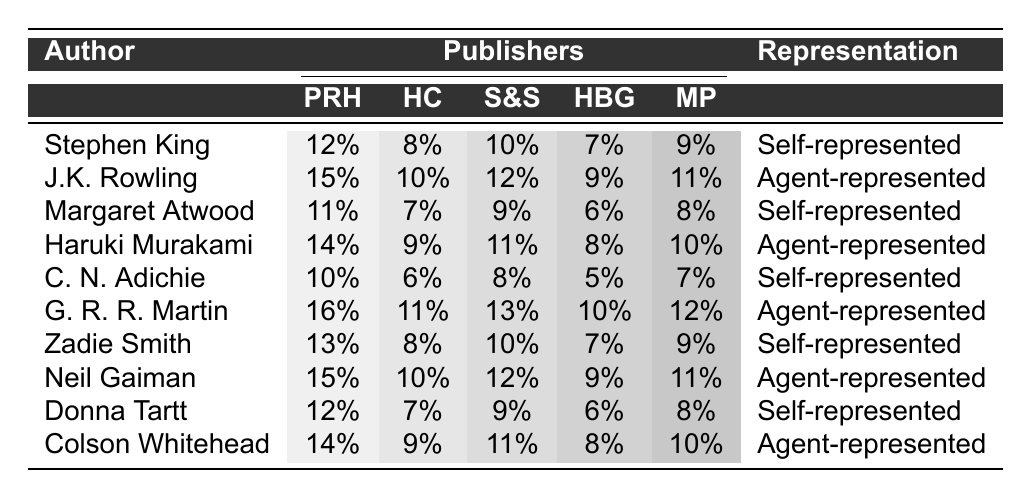What's the highest royalty rate for self-represented authors? By looking at the table, the highest royalty rate for self-represented authors is found under G. R. R. Martin, which is 16%.
Answer: 16% What is the lowest royalty rate offered by Penguin Random House? Upon examining the table, the lowest royalty rate offered by Penguin Random House is 10%, which applies to Chimamanda Ngozi Adichie.
Answer: 10% How many authors are self-represented? Counting the authors listed under the "Representation" column that state "Self-represented," there are five such authors: Stephen King, Margaret Atwood, Chimamanda Ngozi Adichie, Zadie Smith, and Donna Tartt.
Answer: 5 What is the average royalty rate for agent-represented authors? First, I will sum the royalty rates for agent-represented authors: (15 + 10 + 14 + 16 + 15 + 14) = 84. Next, I will divide by the number of authors, which is 6. So, the average is 84/6 = 14%.
Answer: 14% Is J.K. Rowling's royalty rate higher than Neil Gaiman's? Checking the rates, J.K. Rowling has a rate of 15% while Neil Gaiman has a rate of 15%, which means J.K. Rowling's rate is not higher.
Answer: No Which author has the highest average royalty rate across all publishers? To find this, I calculate each author's total royalty rate and divide by the number of publishers. Stephen King's total is 56 (12+8+10+7+9), average = 11.2; J.K. Rowling's total is 57 (15+10+12+9+11), average = 11.4; and so on for each author. Haruki Murakami has the highest total of 52 (14+9+11+8+10) for an average of 10.4%. Comparing all, G. R. R. Martin has the overall highest at an average of 12.4%.
Answer: G. R. R. Martin What percentage of authors represented by agents have a royalty rate of 12% or higher? First, I count the agent-represented authors: there are 5 total. Then, I check how many among them have rates of 12% or higher: J.K. Rowling (15%), G. R. R. Martin (16%), Neil Gaiman (15%), and Colson Whitehead (14%) meet this criterion, giving us 4 out of 5. Thus, 4/5 = 0.8 or 80%.
Answer: 80% Are there any authors with the same royalty rates across all publishers? By analyzing the rows in the table, there are no authors listed under the same representation category with identical royalty rates for all publishers.
Answer: No 